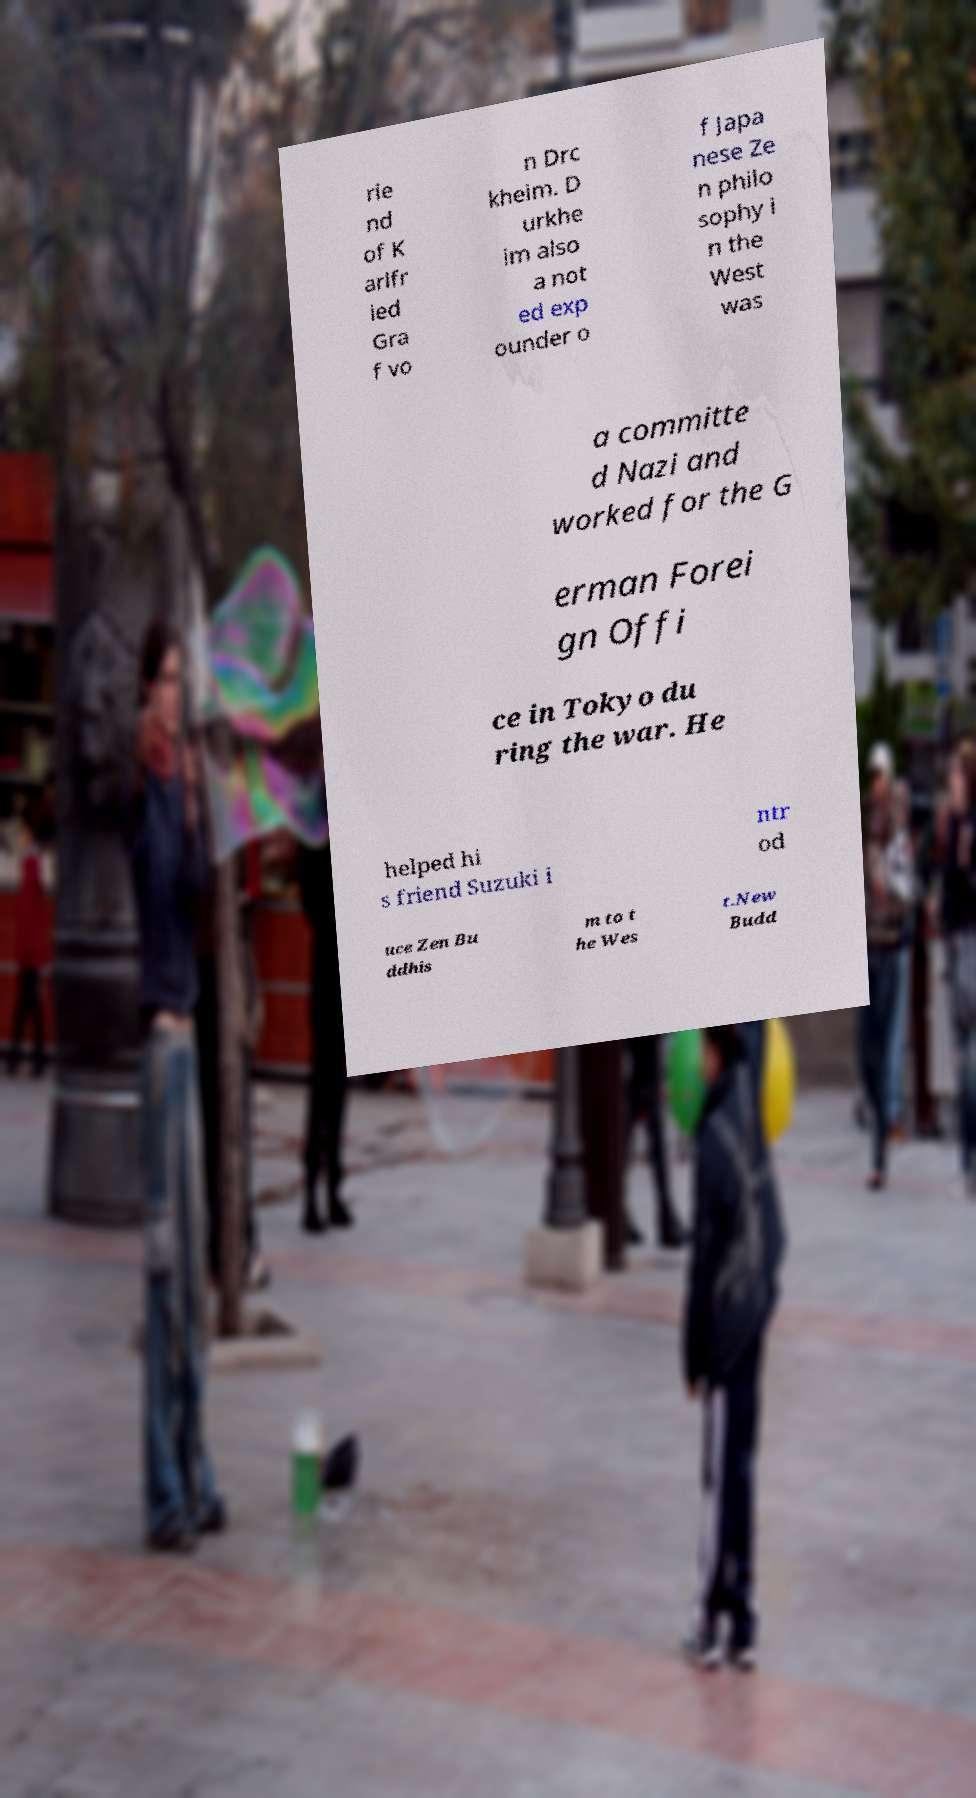Please read and relay the text visible in this image. What does it say? rie nd of K arlfr ied Gra f vo n Drc kheim. D urkhe im also a not ed exp ounder o f Japa nese Ze n philo sophy i n the West was a committe d Nazi and worked for the G erman Forei gn Offi ce in Tokyo du ring the war. He helped hi s friend Suzuki i ntr od uce Zen Bu ddhis m to t he Wes t.New Budd 